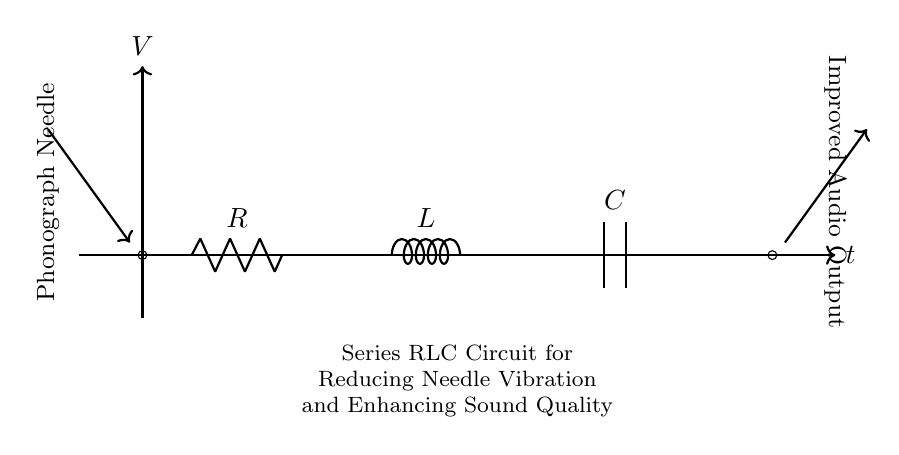What are the components in this circuit? The circuit consists of a resistor, inductor, and capacitor, which are connected in series. This is indicated by their symbols in the diagram.
Answer: Resistor, inductor, capacitor What is the function of the resistor in this circuit? The resistor limits the current flow and dissipates energy in the form of heat, which helps to reduce vibrations from the phonograph needle. This is essential for sound quality improvements.
Answer: Current limiting What is the output of this RLC circuit? The output is labeled as "Improved Audio Output" and is meant to indicate that the circuit enhances the sound produced by the phonograph by reducing needle vibrations.
Answer: Improved audio output Why is the series configuration chosen for this circuit? The series configuration allows for the combined effects of resistance, inductance, and capacitance, which collectively work to smooth out and filter vibrations. This is necessary for optimal audio performance.
Answer: Smoothing vibrations What role does the inductor play in this circuit? The inductor stores energy in a magnetic field and helps to counteract sudden changes in current, effectively reducing fluctuations in the output signal. This contributes to stabilizing the audio signal.
Answer: Counteract current changes How does the capacitor affect the sound quality? The capacitor stores and releases energy, smoothing out voltage fluctuations over time and helping to filter high-frequency noise, ultimately enhancing sound quality.
Answer: Smoothing voltage fluctuations 